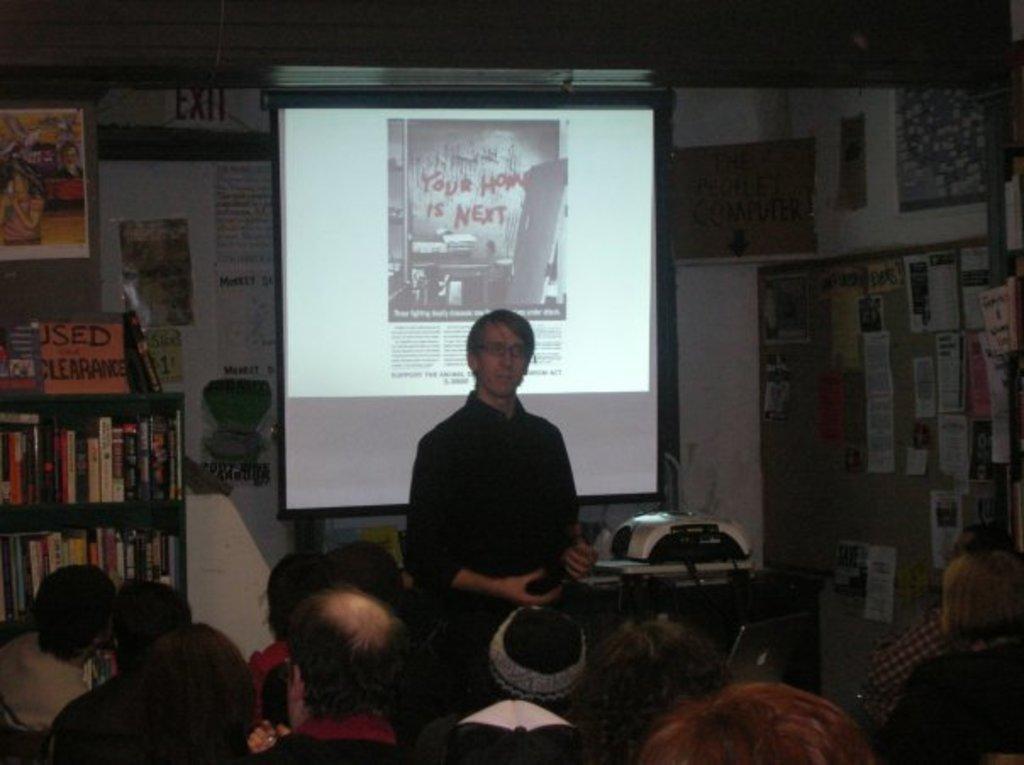In one or two sentences, can you explain what this image depicts? In this image in the center there is one man is standing and talking, at the bottom there are some people who are sitting and in the background there is a screen and on the left side there is one book rack. In that book rack there are some books, and in the background there is a wall. On the wall there are some posters and there is one projector in the center. 